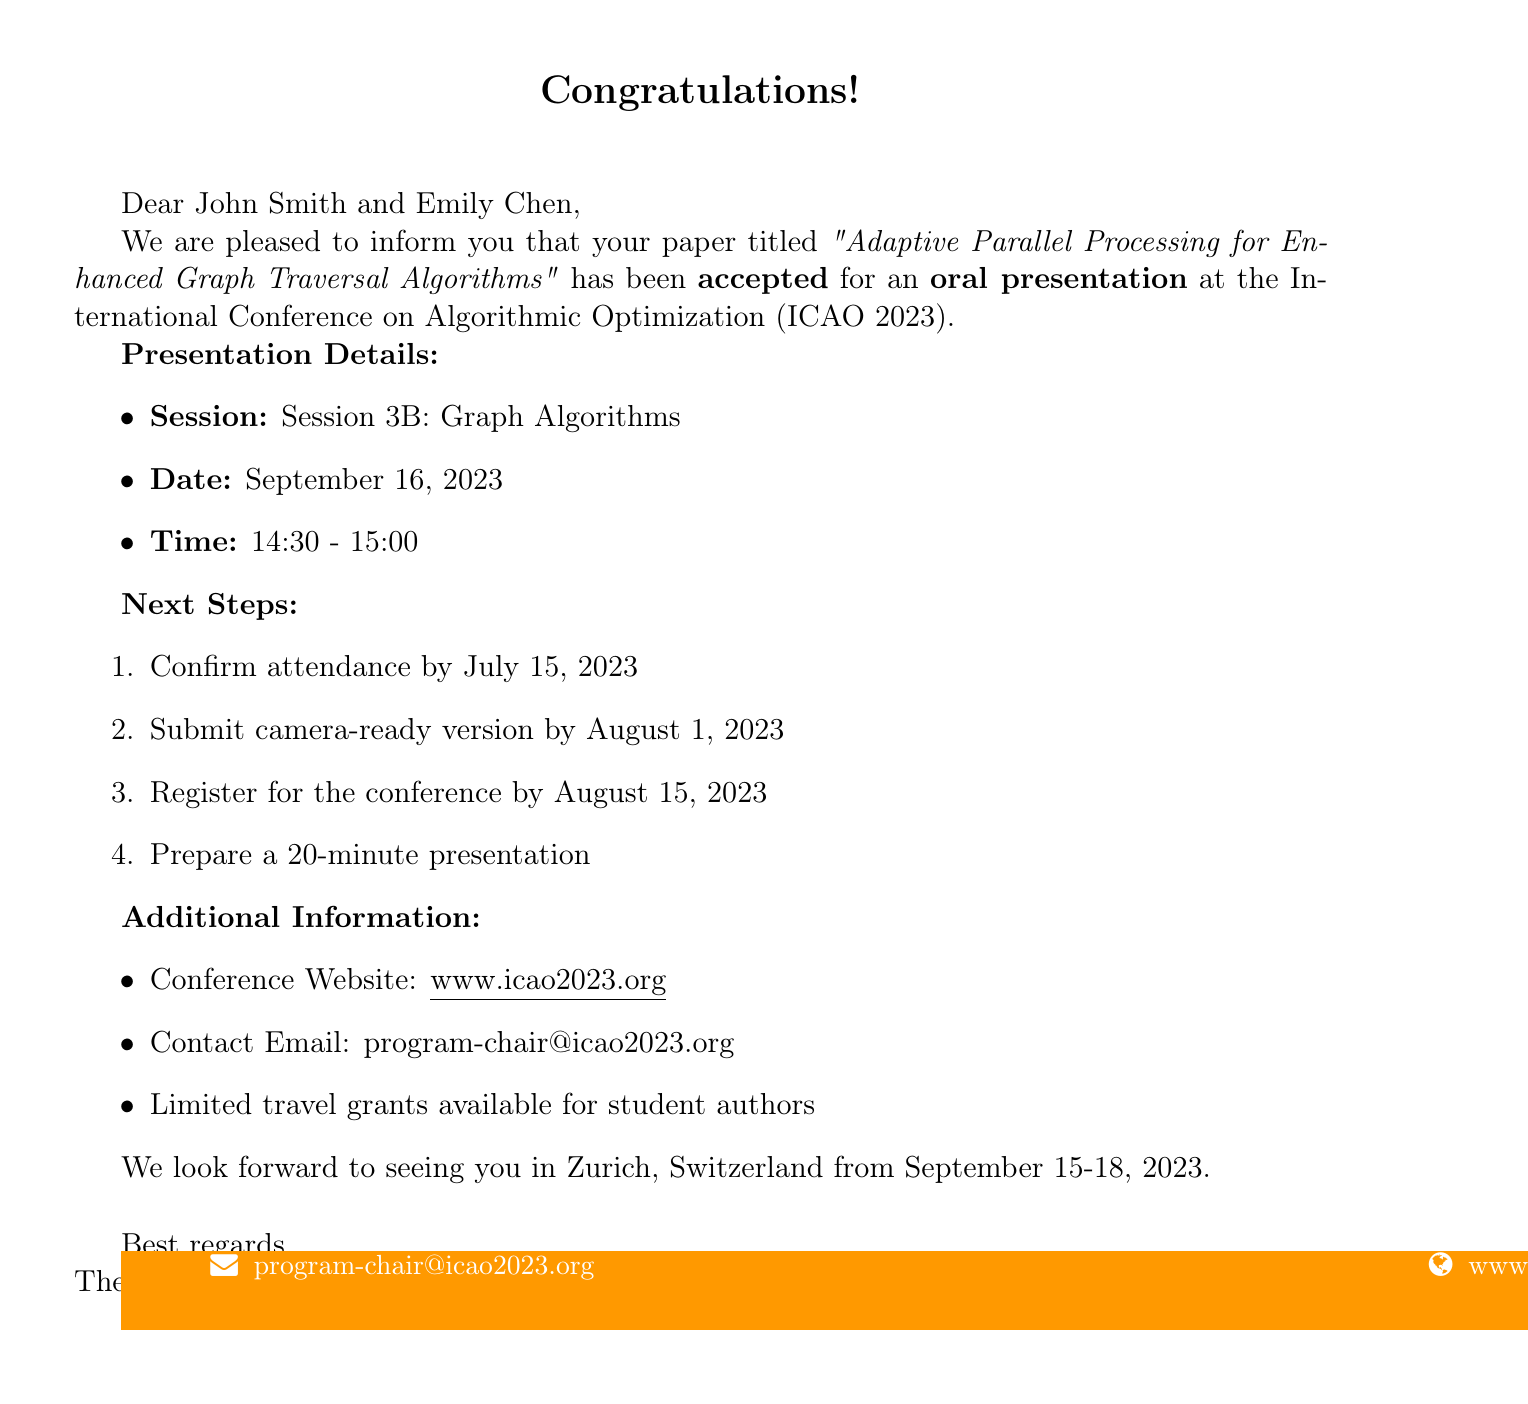What is the name of the conference? The name of the conference is listed at the top of the document as "International Conference on Algorithmic Optimization (ICAO 2023)."
Answer: International Conference on Algorithmic Optimization (ICAO 2023) What are the presentation details session name? The session name for the presentation is provided under the presentation details in an itemized list.
Answer: Session 3B: Graph Algorithms What is the date of the presentation? The date of the presentation is specified in the text, which is clearly stated.
Answer: September 16, 2023 What is the confirmation attendance deadline? The confirmation attendance deadline is outlined in the next steps section of the document.
Answer: July 15, 2023 How long is the presentation? The required duration for the presentation is mentioned in the next steps section.
Answer: 20-minute presentation What is the location of the conference? The location of the conference is mentioned at the beginning of the document, specifying where it will take place.
Answer: Zurich, Switzerland What is the email address to contact for more information? The contact email is noted in the additional information section towards the bottom of the document.
Answer: program-chair@icao2023.org Is there travel grant availability? This information is provided under the additional information section, stating the availability for specific groups.
Answer: Limited travel grants available for student authors 